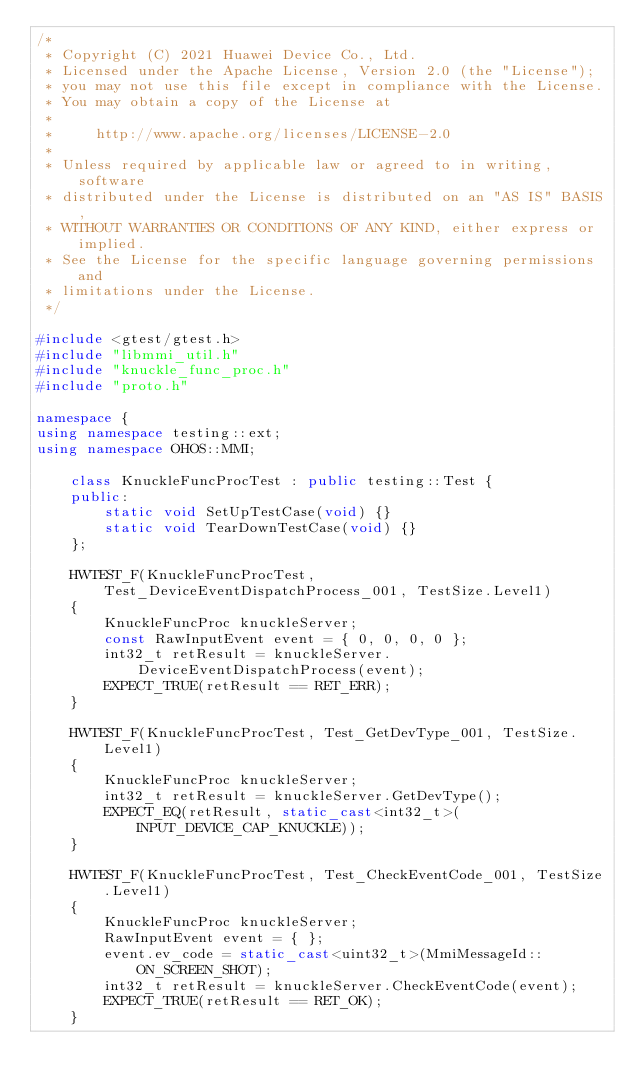<code> <loc_0><loc_0><loc_500><loc_500><_C++_>/*
 * Copyright (C) 2021 Huawei Device Co., Ltd.
 * Licensed under the Apache License, Version 2.0 (the "License");
 * you may not use this file except in compliance with the License.
 * You may obtain a copy of the License at
 *
 *     http://www.apache.org/licenses/LICENSE-2.0
 *
 * Unless required by applicable law or agreed to in writing, software
 * distributed under the License is distributed on an "AS IS" BASIS,
 * WITHOUT WARRANTIES OR CONDITIONS OF ANY KIND, either express or implied.
 * See the License for the specific language governing permissions and
 * limitations under the License.
 */

#include <gtest/gtest.h>
#include "libmmi_util.h"
#include "knuckle_func_proc.h"
#include "proto.h"

namespace {
using namespace testing::ext;
using namespace OHOS::MMI;

    class KnuckleFuncProcTest : public testing::Test {
    public:
        static void SetUpTestCase(void) {}
        static void TearDownTestCase(void) {}
    };

    HWTEST_F(KnuckleFuncProcTest, Test_DeviceEventDispatchProcess_001, TestSize.Level1)
    {
        KnuckleFuncProc knuckleServer;
        const RawInputEvent event = { 0, 0, 0, 0 };
        int32_t retResult = knuckleServer.DeviceEventDispatchProcess(event);
        EXPECT_TRUE(retResult == RET_ERR);
    }

    HWTEST_F(KnuckleFuncProcTest, Test_GetDevType_001, TestSize.Level1)
    {
        KnuckleFuncProc knuckleServer;
        int32_t retResult = knuckleServer.GetDevType();
        EXPECT_EQ(retResult, static_cast<int32_t>(INPUT_DEVICE_CAP_KNUCKLE));
    }

    HWTEST_F(KnuckleFuncProcTest, Test_CheckEventCode_001, TestSize.Level1)
    {
        KnuckleFuncProc knuckleServer;
        RawInputEvent event = { };
        event.ev_code = static_cast<uint32_t>(MmiMessageId::ON_SCREEN_SHOT);
        int32_t retResult = knuckleServer.CheckEventCode(event);
        EXPECT_TRUE(retResult == RET_OK);
    }
</code> 